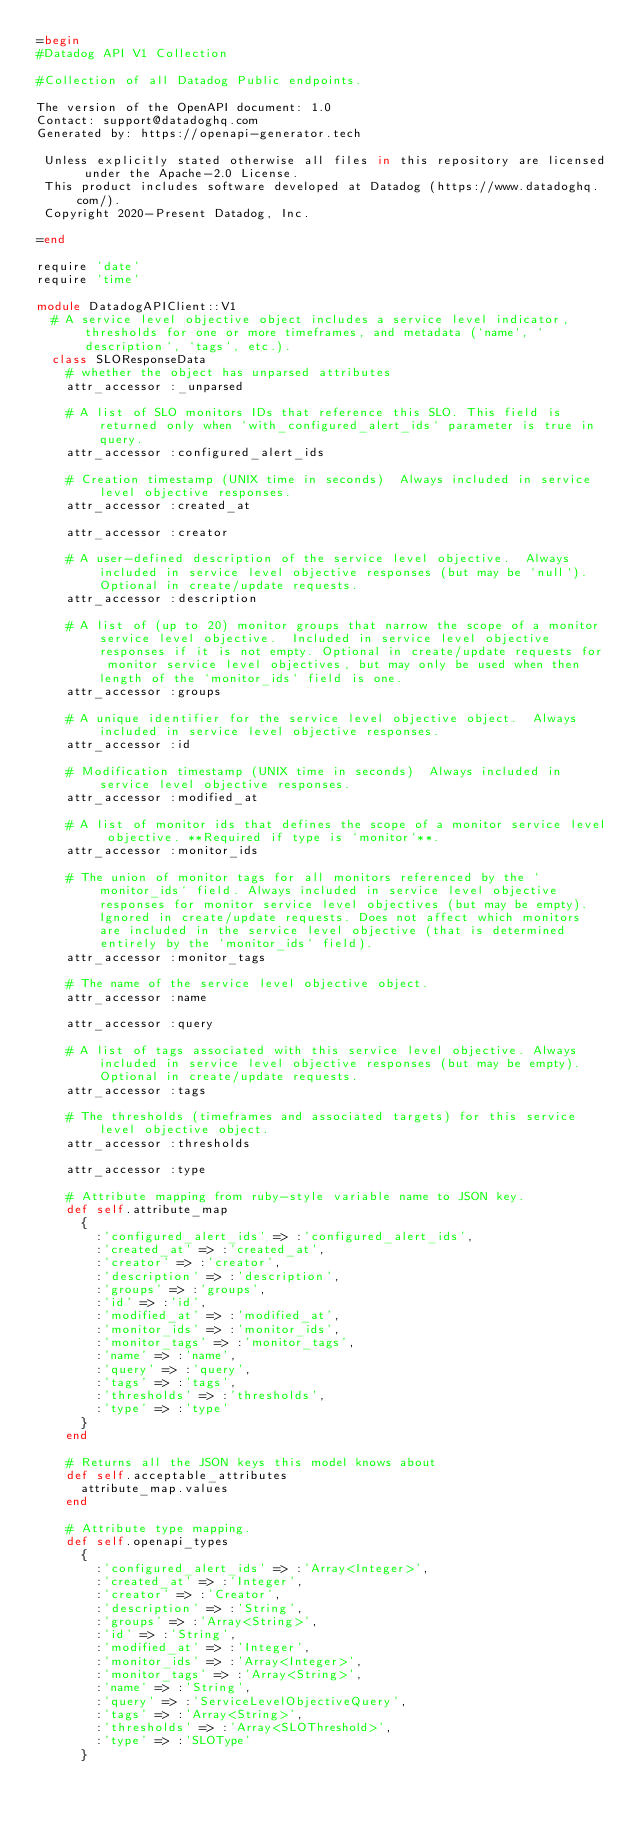Convert code to text. <code><loc_0><loc_0><loc_500><loc_500><_Ruby_>=begin
#Datadog API V1 Collection

#Collection of all Datadog Public endpoints.

The version of the OpenAPI document: 1.0
Contact: support@datadoghq.com
Generated by: https://openapi-generator.tech

 Unless explicitly stated otherwise all files in this repository are licensed under the Apache-2.0 License.
 This product includes software developed at Datadog (https://www.datadoghq.com/).
 Copyright 2020-Present Datadog, Inc.

=end

require 'date'
require 'time'

module DatadogAPIClient::V1
  # A service level objective object includes a service level indicator, thresholds for one or more timeframes, and metadata (`name`, `description`, `tags`, etc.).
  class SLOResponseData
    # whether the object has unparsed attributes
    attr_accessor :_unparsed

    # A list of SLO monitors IDs that reference this SLO. This field is returned only when `with_configured_alert_ids` parameter is true in query.
    attr_accessor :configured_alert_ids

    # Creation timestamp (UNIX time in seconds)  Always included in service level objective responses.
    attr_accessor :created_at

    attr_accessor :creator

    # A user-defined description of the service level objective.  Always included in service level objective responses (but may be `null`). Optional in create/update requests.
    attr_accessor :description

    # A list of (up to 20) monitor groups that narrow the scope of a monitor service level objective.  Included in service level objective responses if it is not empty. Optional in create/update requests for monitor service level objectives, but may only be used when then length of the `monitor_ids` field is one.
    attr_accessor :groups

    # A unique identifier for the service level objective object.  Always included in service level objective responses.
    attr_accessor :id

    # Modification timestamp (UNIX time in seconds)  Always included in service level objective responses.
    attr_accessor :modified_at

    # A list of monitor ids that defines the scope of a monitor service level objective. **Required if type is `monitor`**.
    attr_accessor :monitor_ids

    # The union of monitor tags for all monitors referenced by the `monitor_ids` field. Always included in service level objective responses for monitor service level objectives (but may be empty). Ignored in create/update requests. Does not affect which monitors are included in the service level objective (that is determined entirely by the `monitor_ids` field).
    attr_accessor :monitor_tags

    # The name of the service level objective object.
    attr_accessor :name

    attr_accessor :query

    # A list of tags associated with this service level objective. Always included in service level objective responses (but may be empty). Optional in create/update requests.
    attr_accessor :tags

    # The thresholds (timeframes and associated targets) for this service level objective object.
    attr_accessor :thresholds

    attr_accessor :type

    # Attribute mapping from ruby-style variable name to JSON key.
    def self.attribute_map
      {
        :'configured_alert_ids' => :'configured_alert_ids',
        :'created_at' => :'created_at',
        :'creator' => :'creator',
        :'description' => :'description',
        :'groups' => :'groups',
        :'id' => :'id',
        :'modified_at' => :'modified_at',
        :'monitor_ids' => :'monitor_ids',
        :'monitor_tags' => :'monitor_tags',
        :'name' => :'name',
        :'query' => :'query',
        :'tags' => :'tags',
        :'thresholds' => :'thresholds',
        :'type' => :'type'
      }
    end

    # Returns all the JSON keys this model knows about
    def self.acceptable_attributes
      attribute_map.values
    end

    # Attribute type mapping.
    def self.openapi_types
      {
        :'configured_alert_ids' => :'Array<Integer>',
        :'created_at' => :'Integer',
        :'creator' => :'Creator',
        :'description' => :'String',
        :'groups' => :'Array<String>',
        :'id' => :'String',
        :'modified_at' => :'Integer',
        :'monitor_ids' => :'Array<Integer>',
        :'monitor_tags' => :'Array<String>',
        :'name' => :'String',
        :'query' => :'ServiceLevelObjectiveQuery',
        :'tags' => :'Array<String>',
        :'thresholds' => :'Array<SLOThreshold>',
        :'type' => :'SLOType'
      }</code> 